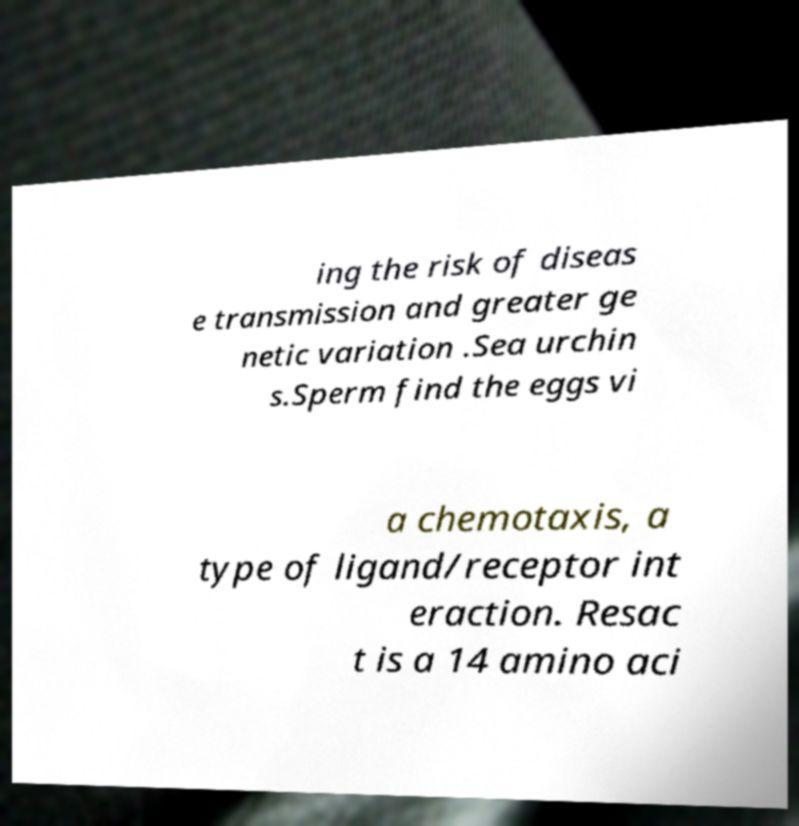Please identify and transcribe the text found in this image. ing the risk of diseas e transmission and greater ge netic variation .Sea urchin s.Sperm find the eggs vi a chemotaxis, a type of ligand/receptor int eraction. Resac t is a 14 amino aci 